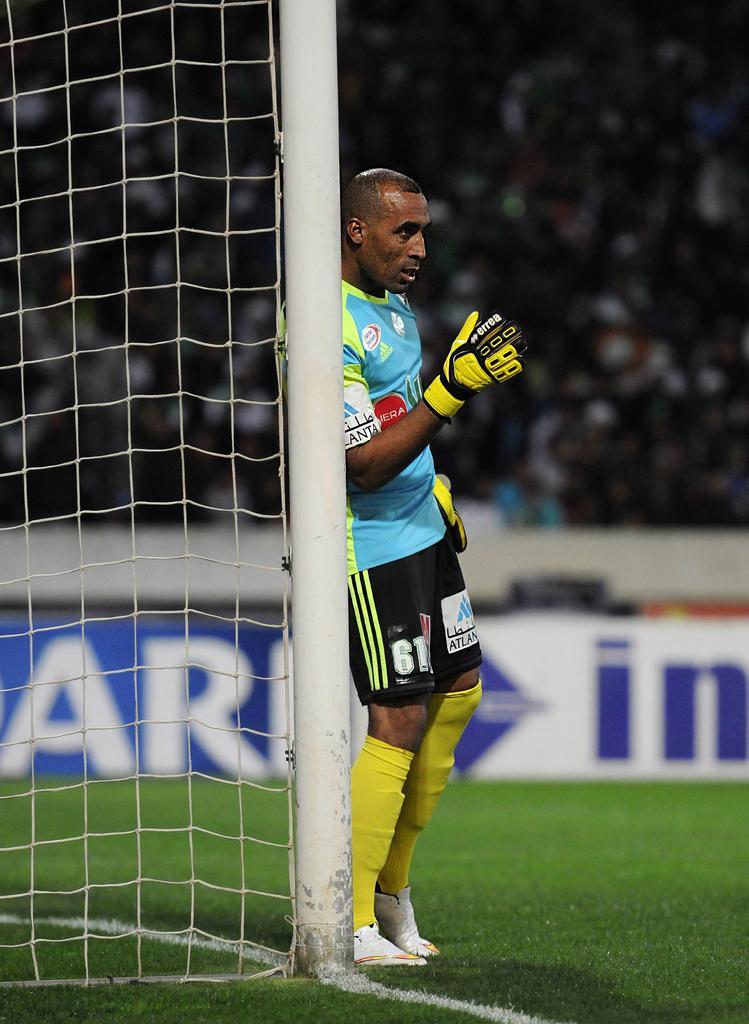Could you give a brief overview of what you see in this image? This image consists of a man wearing a jersey. He is also wearing a gloves. At the bottom, we can see green grass. On the left, there is a net. In the background, there is a huge crowd. Behind the man, we can see a banner. 